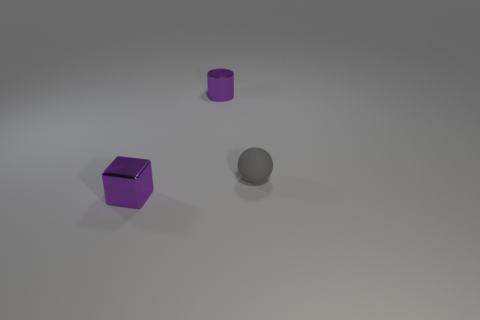Add 2 tiny cylinders. How many objects exist? 5 Subtract all balls. How many objects are left? 2 Subtract all tiny shiny things. Subtract all cylinders. How many objects are left? 0 Add 3 matte things. How many matte things are left? 4 Add 3 small shiny cylinders. How many small shiny cylinders exist? 4 Subtract 0 blue balls. How many objects are left? 3 